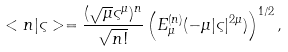<formula> <loc_0><loc_0><loc_500><loc_500>< n | \varsigma > = \frac { ( \sqrt { \mu } \varsigma ^ { \mu } ) ^ { n } } { \sqrt { n ! } } \left ( E _ { \mu } ^ { ( n ) } ( - \mu | \varsigma | ^ { 2 \mu } ) \right ) ^ { 1 / 2 } ,</formula> 